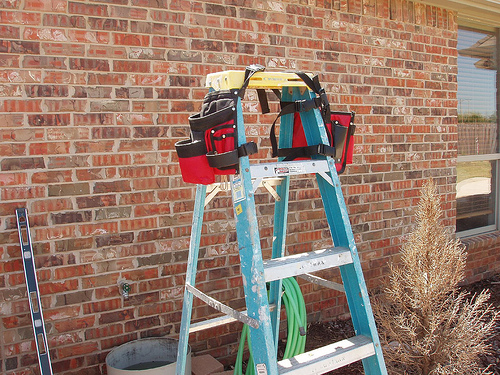<image>
Is there a ladder on the stone? No. The ladder is not positioned on the stone. They may be near each other, but the ladder is not supported by or resting on top of the stone. 